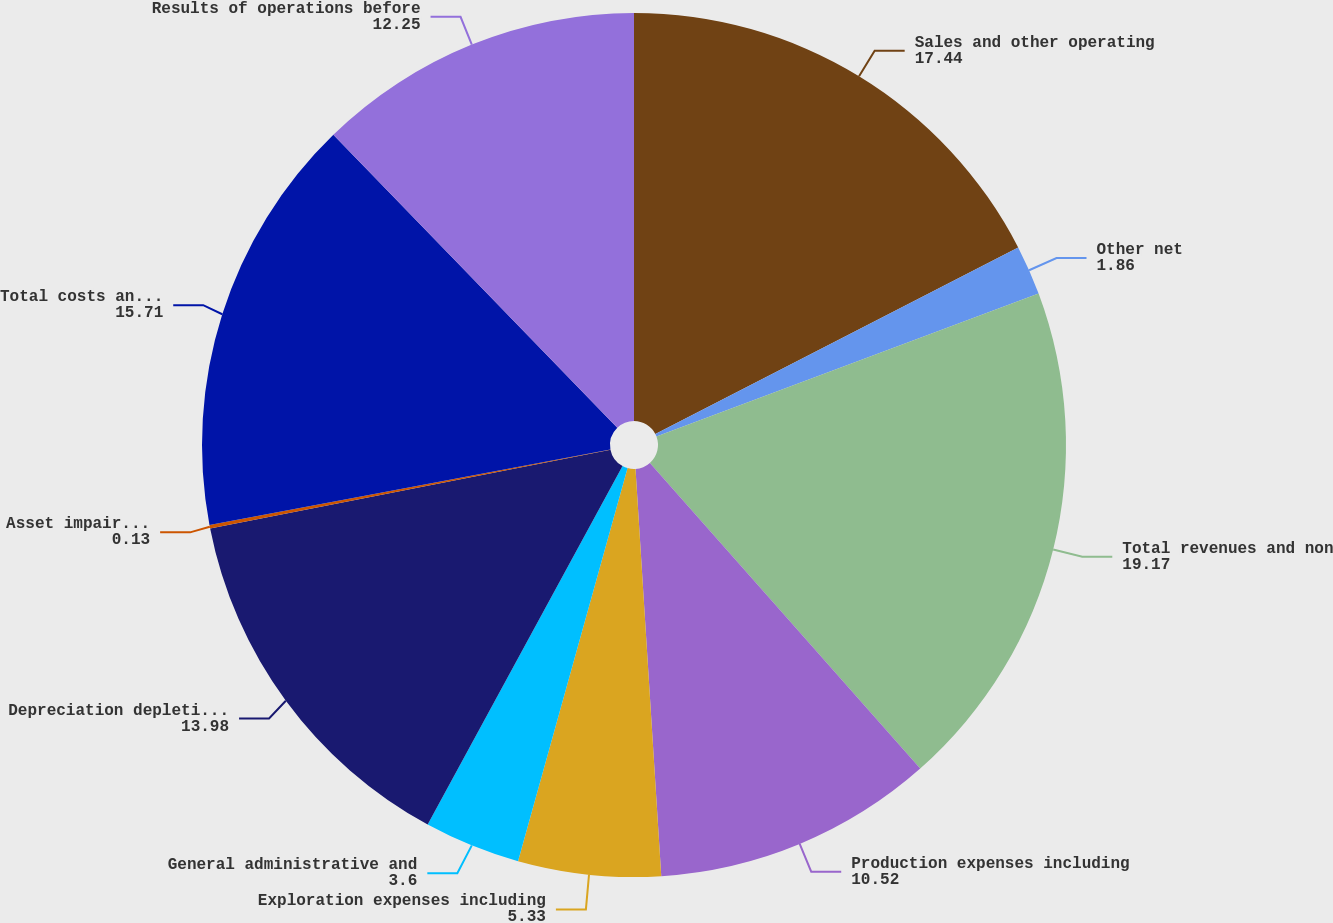Convert chart to OTSL. <chart><loc_0><loc_0><loc_500><loc_500><pie_chart><fcel>Sales and other operating<fcel>Other net<fcel>Total revenues and non<fcel>Production expenses including<fcel>Exploration expenses including<fcel>General administrative and<fcel>Depreciation depletion and<fcel>Asset impairments<fcel>Total costs and expenses<fcel>Results of operations before<nl><fcel>17.44%<fcel>1.86%<fcel>19.17%<fcel>10.52%<fcel>5.33%<fcel>3.6%<fcel>13.98%<fcel>0.13%<fcel>15.71%<fcel>12.25%<nl></chart> 